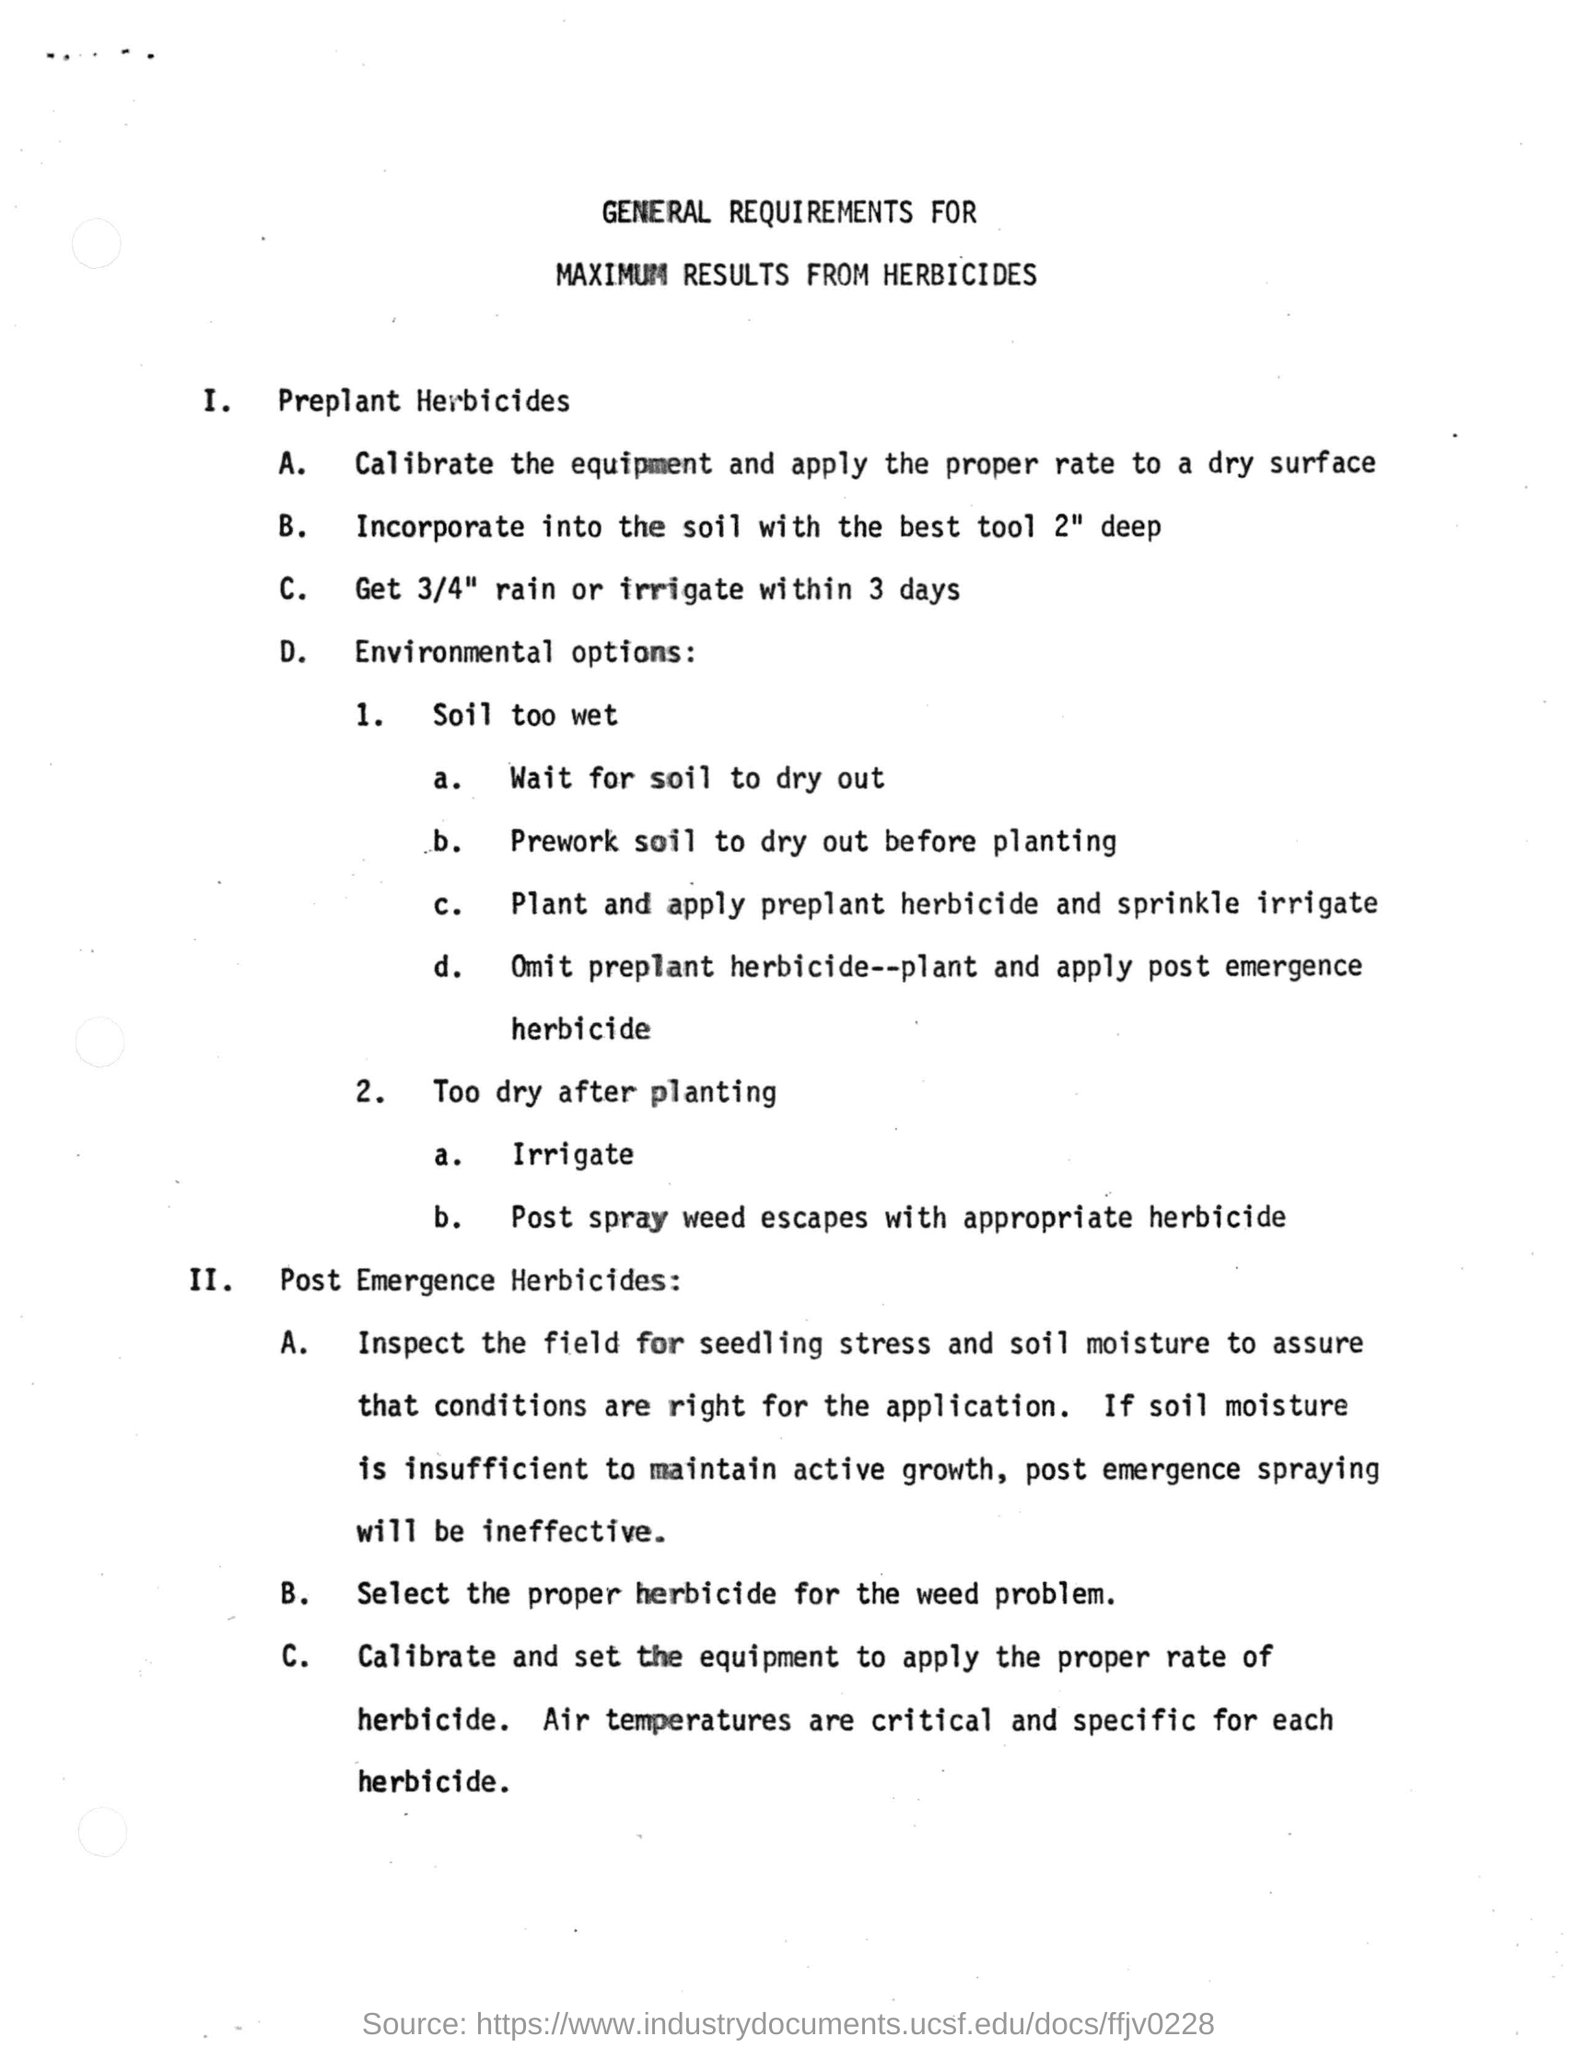Draw attention to some important aspects in this diagram. It is recommended to incorporate soil to a depth of 2 inches with the best tool to ensure proper nutrient absorption and soil health. It is expected that 3/4 of the recommended amount of rain will be received. It is important to wait for soil to dry out if it is too wet, as excess moisture can hinder plant growth and crop yield. 